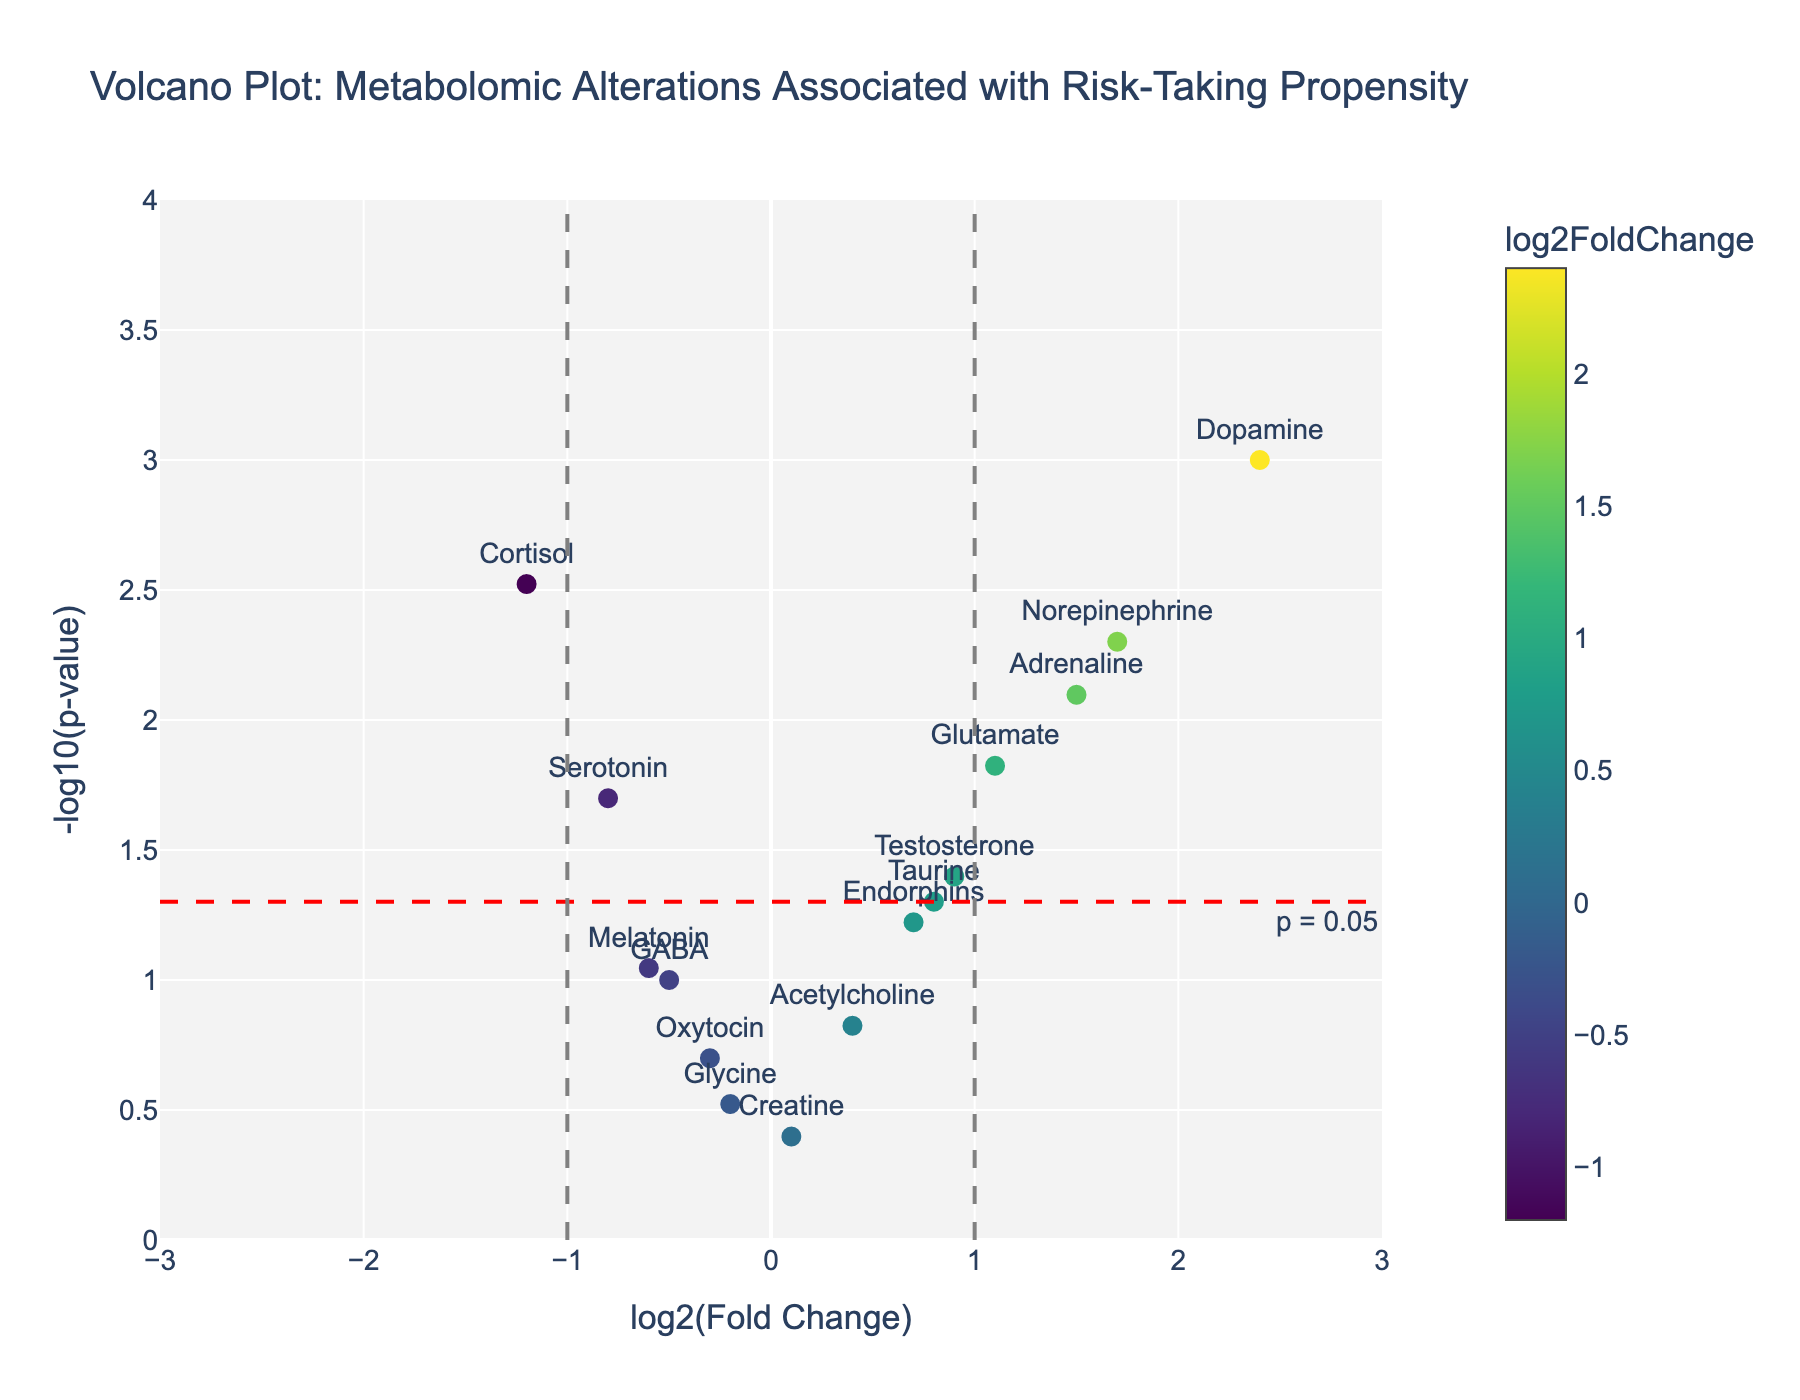How many metabolites have a p-value less than 0.05 and a log2 fold change greater than 1? To answer this, count the data points in the figure on the right side of the vertical line at log2 fold change = 1, and above the horizontal threshold line at -log10(p-value) = 1.3 (corresponding to p-value < 0.05). There are two such metabolites: Dopamine and Norepinephrine.
Answer: 2 Which metabolite has the highest log2 fold change? Observe the data points on the horizontal axis (log2 fold change) and identify the one with the highest value. Dopamine has the highest log2 fold change at 2.4.
Answer: Dopamine What is the -log10(p-value) for Serotonin? Locate the data point for Serotonin and observe its y-axis value (-log10(p-value)). According to the data, Serotonin has a p-value of 0.02, thus its -log10(p-value) is -log10(0.02) = 1.7.
Answer: 1.7 Which metabolites are below the horizontal red line indicating p = 0.05? The horizontal red line is at -log10(p-value) = 1.3. Count the data points below this threshold. The metabolites are GABA, Oxytocin, Melatonin, Acetylcholine, Glycine, Creatine, and Endorphins.
Answer: 7 What is the log2 fold change and p-value for Cortisol? Find Cortisol on the plot and check its coordinates on the x-axis and y-axis. Cortisol has a log2 fold change of -1.2 and a p-value of 0.003.
Answer: -1.2 and 0.003 Which metabolites show a statistically significant negative log2 fold change? Identify metabolites with p-values less than 0.05 (above the horizontal threshold line) and negative log2 fold changes (left of the center line). This includes Cortisol and Serotonin.
Answer: Cortisol and Serotonin Is Glutamate considered statistically significant? Check Glutamate's position relative to the horizontal line at -log10(p-value) = 1.3. Since Glutamate is above this line with a p-value < 0.05, then it is statistically significant.
Answer: Yes Which metabolite has a log2 fold change closest to 0 but still considered statistically significant? Among the statistically significant points (above the horizontal line at -log10(p-value) = 1.3), find the one with a log2 fold change value closest to 0. Testosterone with a log2 fold change of 0.9 fits this criterion.
Answer: Testosterone What are the colors representing different levels of log2 fold changes? Examine the color scale, which is based on the Viridis color scheme, attached to the right side of the plot. The color gradient indicates different log2 fold change values, ranging from dark colors (negative values) to bright colors (positive values).
Answer: Viridis color scale How many metabolites have a log2 fold change between -1 and 1 but are not considered statistically significant? Look at data points within the vertical lines at log2 fold change = -1 and 1, and below the horizontal line at -log10(p-value) = 1.3. The metabolites are GABA, Endorphins, Melatonin, Acetylcholine, Glycine, Taurine, and Creatine.
Answer: 7 